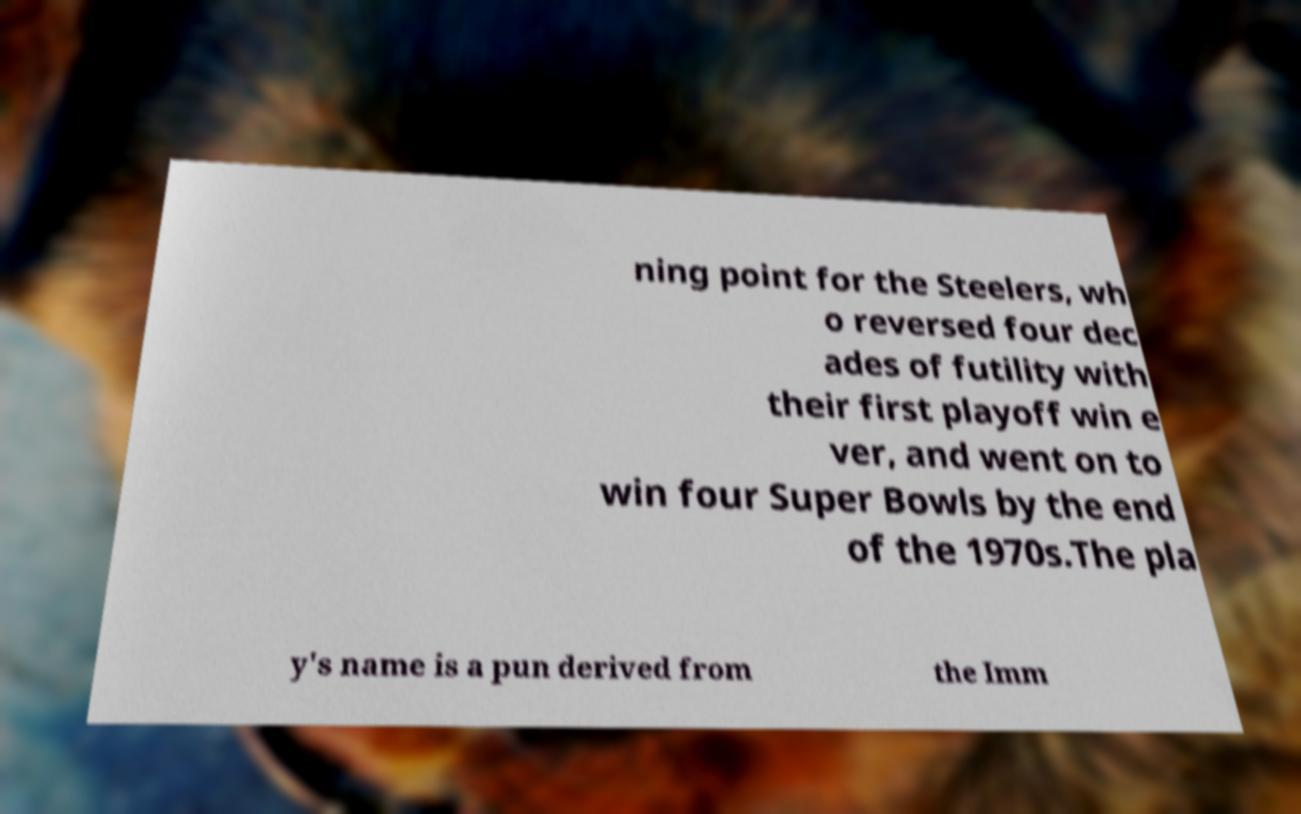There's text embedded in this image that I need extracted. Can you transcribe it verbatim? ning point for the Steelers, wh o reversed four dec ades of futility with their first playoff win e ver, and went on to win four Super Bowls by the end of the 1970s.The pla y's name is a pun derived from the Imm 